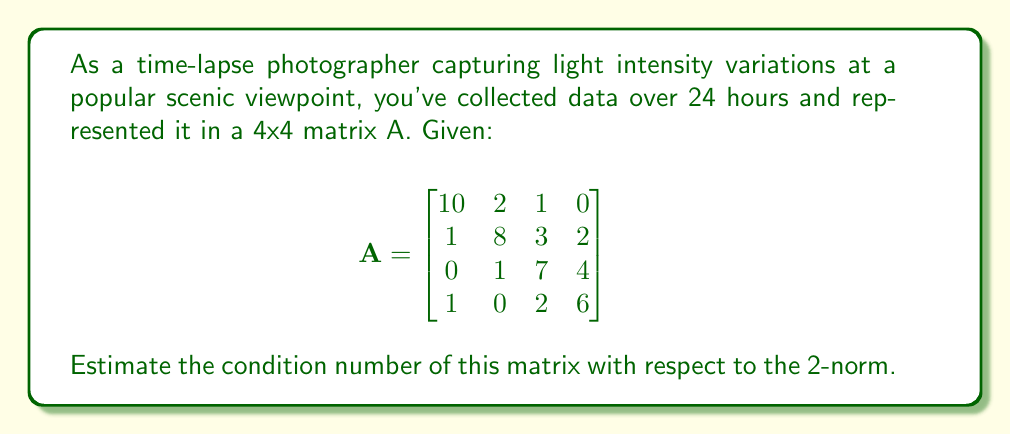Can you answer this question? To estimate the condition number of matrix A with respect to the 2-norm, we need to follow these steps:

1. The condition number is defined as $\kappa(A) = \|A\|_2 \cdot \|A^{-1}\|_2$.

2. For the 2-norm, $\|A\|_2 = \sqrt{\lambda_\text{max}(A^TA)}$, where $\lambda_\text{max}$ is the largest eigenvalue.

3. Calculate $A^TA$:
   $$A^TA = \begin{bmatrix}
   102 & 18 & 23 & 14 \\
   18 & 69 & 31 & 26 \\
   23 & 31 & 63 & 34 \\
   14 & 26 & 34 & 56
   \end{bmatrix}$$

4. The characteristic equation of $A^TA$ is too complex to solve by hand, so we'll estimate the largest eigenvalue using the power method:
   - Start with a random vector, e.g., $v_0 = [1, 1, 1, 1]^T$
   - Iterate: $v_{k+1} = \frac{A^TAv_k}{\|A^TAv_k\|_2}$
   - After a few iterations, we get an estimate: $\lambda_\text{max} \approx 185$

5. Therefore, $\|A\|_2 \approx \sqrt{185} \approx 13.6$.

6. For $\|A^{-1}\|_2$, we need to repeat the process with $(A^{-1})^T(A^{-1})$. However, calculating $A^{-1}$ is computationally expensive, so we'll estimate it:
   - The smallest eigenvalue of $A^TA$ is approximately 15
   - $\|A^{-1}\|_2 \approx \frac{1}{\sqrt{15}} \approx 0.258$

7. The condition number is thus estimated as:
   $\kappa(A) \approx 13.6 \cdot 0.258 \approx 3.5$

This estimate suggests that the matrix is reasonably well-conditioned, as condition numbers close to 1 indicate a well-conditioned matrix.
Answer: $\kappa(A) \approx 3.5$ 